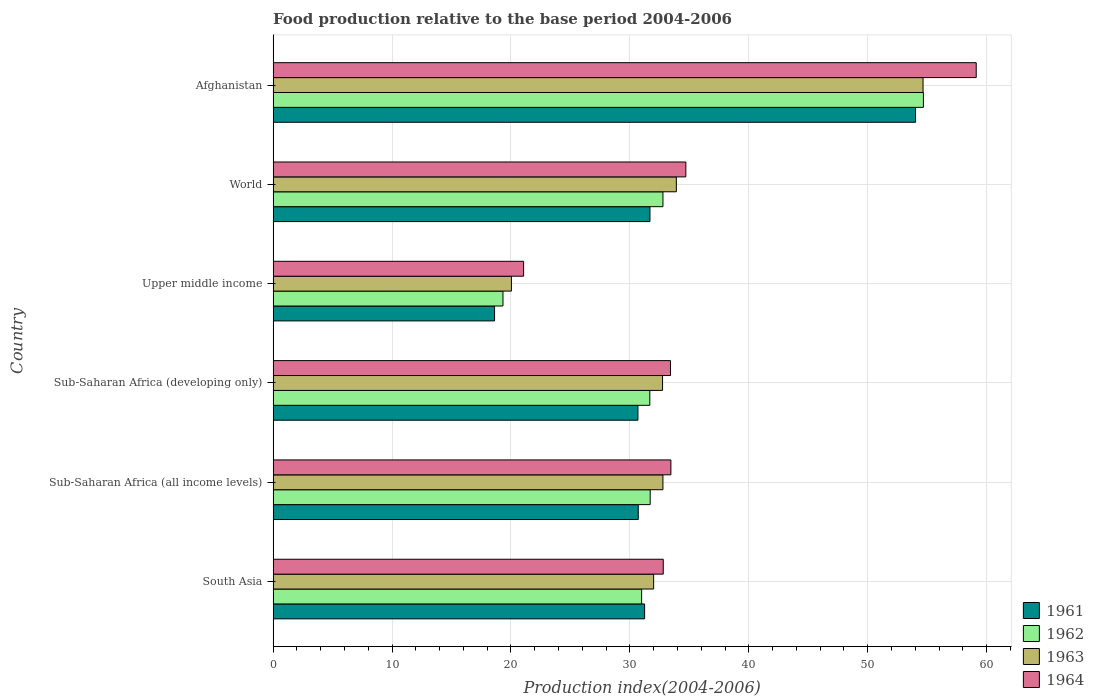How many different coloured bars are there?
Your answer should be very brief. 4. How many groups of bars are there?
Your response must be concise. 6. Are the number of bars on each tick of the Y-axis equal?
Your answer should be very brief. Yes. How many bars are there on the 5th tick from the top?
Offer a terse response. 4. What is the label of the 2nd group of bars from the top?
Your response must be concise. World. What is the food production index in 1961 in Sub-Saharan Africa (developing only)?
Provide a short and direct response. 30.68. Across all countries, what is the maximum food production index in 1962?
Provide a short and direct response. 54.68. Across all countries, what is the minimum food production index in 1964?
Offer a very short reply. 21.06. In which country was the food production index in 1962 maximum?
Your answer should be very brief. Afghanistan. In which country was the food production index in 1963 minimum?
Provide a succinct answer. Upper middle income. What is the total food production index in 1964 in the graph?
Make the answer very short. 214.55. What is the difference between the food production index in 1962 in Afghanistan and that in Upper middle income?
Provide a succinct answer. 35.35. What is the difference between the food production index in 1963 in Sub-Saharan Africa (all income levels) and the food production index in 1962 in Upper middle income?
Provide a short and direct response. 13.45. What is the average food production index in 1961 per country?
Make the answer very short. 32.82. What is the difference between the food production index in 1961 and food production index in 1962 in World?
Your answer should be very brief. -1.09. In how many countries, is the food production index in 1961 greater than 20 ?
Make the answer very short. 5. What is the ratio of the food production index in 1961 in South Asia to that in World?
Provide a succinct answer. 0.99. Is the food production index in 1964 in Sub-Saharan Africa (all income levels) less than that in World?
Your response must be concise. Yes. What is the difference between the highest and the second highest food production index in 1961?
Your response must be concise. 22.33. What is the difference between the highest and the lowest food production index in 1963?
Your answer should be very brief. 34.61. In how many countries, is the food production index in 1964 greater than the average food production index in 1964 taken over all countries?
Provide a short and direct response. 1. Is the sum of the food production index in 1964 in Afghanistan and Sub-Saharan Africa (all income levels) greater than the maximum food production index in 1963 across all countries?
Your answer should be compact. Yes. Is it the case that in every country, the sum of the food production index in 1961 and food production index in 1962 is greater than the sum of food production index in 1963 and food production index in 1964?
Make the answer very short. No. What does the 3rd bar from the top in World represents?
Offer a terse response. 1962. What is the difference between two consecutive major ticks on the X-axis?
Your answer should be compact. 10. Are the values on the major ticks of X-axis written in scientific E-notation?
Provide a succinct answer. No. Where does the legend appear in the graph?
Provide a short and direct response. Bottom right. How many legend labels are there?
Offer a terse response. 4. What is the title of the graph?
Your answer should be compact. Food production relative to the base period 2004-2006. What is the label or title of the X-axis?
Offer a terse response. Production index(2004-2006). What is the Production index(2004-2006) in 1961 in South Asia?
Make the answer very short. 31.24. What is the Production index(2004-2006) in 1962 in South Asia?
Offer a very short reply. 30.99. What is the Production index(2004-2006) of 1963 in South Asia?
Your answer should be compact. 32. What is the Production index(2004-2006) in 1964 in South Asia?
Your answer should be very brief. 32.8. What is the Production index(2004-2006) of 1961 in Sub-Saharan Africa (all income levels)?
Your answer should be very brief. 30.7. What is the Production index(2004-2006) of 1962 in Sub-Saharan Africa (all income levels)?
Keep it short and to the point. 31.71. What is the Production index(2004-2006) in 1963 in Sub-Saharan Africa (all income levels)?
Your response must be concise. 32.78. What is the Production index(2004-2006) in 1964 in Sub-Saharan Africa (all income levels)?
Provide a succinct answer. 33.45. What is the Production index(2004-2006) in 1961 in Sub-Saharan Africa (developing only)?
Ensure brevity in your answer.  30.68. What is the Production index(2004-2006) in 1962 in Sub-Saharan Africa (developing only)?
Provide a short and direct response. 31.68. What is the Production index(2004-2006) of 1963 in Sub-Saharan Africa (developing only)?
Offer a terse response. 32.75. What is the Production index(2004-2006) of 1964 in Sub-Saharan Africa (developing only)?
Provide a succinct answer. 33.41. What is the Production index(2004-2006) of 1961 in Upper middle income?
Provide a succinct answer. 18.62. What is the Production index(2004-2006) in 1962 in Upper middle income?
Ensure brevity in your answer.  19.33. What is the Production index(2004-2006) of 1963 in Upper middle income?
Your answer should be compact. 20.04. What is the Production index(2004-2006) in 1964 in Upper middle income?
Make the answer very short. 21.06. What is the Production index(2004-2006) in 1961 in World?
Offer a terse response. 31.69. What is the Production index(2004-2006) in 1962 in World?
Ensure brevity in your answer.  32.78. What is the Production index(2004-2006) in 1963 in World?
Your response must be concise. 33.91. What is the Production index(2004-2006) in 1964 in World?
Keep it short and to the point. 34.7. What is the Production index(2004-2006) in 1961 in Afghanistan?
Give a very brief answer. 54.02. What is the Production index(2004-2006) of 1962 in Afghanistan?
Give a very brief answer. 54.68. What is the Production index(2004-2006) of 1963 in Afghanistan?
Ensure brevity in your answer.  54.65. What is the Production index(2004-2006) in 1964 in Afghanistan?
Your answer should be very brief. 59.12. Across all countries, what is the maximum Production index(2004-2006) in 1961?
Make the answer very short. 54.02. Across all countries, what is the maximum Production index(2004-2006) of 1962?
Your answer should be compact. 54.68. Across all countries, what is the maximum Production index(2004-2006) in 1963?
Offer a terse response. 54.65. Across all countries, what is the maximum Production index(2004-2006) of 1964?
Your answer should be compact. 59.12. Across all countries, what is the minimum Production index(2004-2006) of 1961?
Offer a terse response. 18.62. Across all countries, what is the minimum Production index(2004-2006) in 1962?
Ensure brevity in your answer.  19.33. Across all countries, what is the minimum Production index(2004-2006) of 1963?
Your answer should be compact. 20.04. Across all countries, what is the minimum Production index(2004-2006) of 1964?
Give a very brief answer. 21.06. What is the total Production index(2004-2006) in 1961 in the graph?
Offer a very short reply. 196.94. What is the total Production index(2004-2006) in 1962 in the graph?
Provide a short and direct response. 201.15. What is the total Production index(2004-2006) in 1963 in the graph?
Provide a succinct answer. 206.11. What is the total Production index(2004-2006) of 1964 in the graph?
Make the answer very short. 214.55. What is the difference between the Production index(2004-2006) in 1961 in South Asia and that in Sub-Saharan Africa (all income levels)?
Your answer should be compact. 0.54. What is the difference between the Production index(2004-2006) in 1962 in South Asia and that in Sub-Saharan Africa (all income levels)?
Provide a short and direct response. -0.72. What is the difference between the Production index(2004-2006) of 1963 in South Asia and that in Sub-Saharan Africa (all income levels)?
Provide a succinct answer. -0.78. What is the difference between the Production index(2004-2006) in 1964 in South Asia and that in Sub-Saharan Africa (all income levels)?
Provide a short and direct response. -0.64. What is the difference between the Production index(2004-2006) of 1961 in South Asia and that in Sub-Saharan Africa (developing only)?
Your answer should be compact. 0.56. What is the difference between the Production index(2004-2006) in 1962 in South Asia and that in Sub-Saharan Africa (developing only)?
Make the answer very short. -0.69. What is the difference between the Production index(2004-2006) of 1963 in South Asia and that in Sub-Saharan Africa (developing only)?
Your response must be concise. -0.75. What is the difference between the Production index(2004-2006) in 1964 in South Asia and that in Sub-Saharan Africa (developing only)?
Keep it short and to the point. -0.61. What is the difference between the Production index(2004-2006) of 1961 in South Asia and that in Upper middle income?
Your answer should be compact. 12.62. What is the difference between the Production index(2004-2006) in 1962 in South Asia and that in Upper middle income?
Your answer should be compact. 11.66. What is the difference between the Production index(2004-2006) in 1963 in South Asia and that in Upper middle income?
Provide a short and direct response. 11.96. What is the difference between the Production index(2004-2006) of 1964 in South Asia and that in Upper middle income?
Provide a short and direct response. 11.74. What is the difference between the Production index(2004-2006) in 1961 in South Asia and that in World?
Make the answer very short. -0.45. What is the difference between the Production index(2004-2006) of 1962 in South Asia and that in World?
Provide a short and direct response. -1.79. What is the difference between the Production index(2004-2006) in 1963 in South Asia and that in World?
Give a very brief answer. -1.91. What is the difference between the Production index(2004-2006) of 1964 in South Asia and that in World?
Give a very brief answer. -1.9. What is the difference between the Production index(2004-2006) of 1961 in South Asia and that in Afghanistan?
Offer a very short reply. -22.78. What is the difference between the Production index(2004-2006) of 1962 in South Asia and that in Afghanistan?
Offer a terse response. -23.69. What is the difference between the Production index(2004-2006) in 1963 in South Asia and that in Afghanistan?
Provide a short and direct response. -22.65. What is the difference between the Production index(2004-2006) in 1964 in South Asia and that in Afghanistan?
Ensure brevity in your answer.  -26.32. What is the difference between the Production index(2004-2006) in 1961 in Sub-Saharan Africa (all income levels) and that in Sub-Saharan Africa (developing only)?
Your response must be concise. 0.03. What is the difference between the Production index(2004-2006) in 1962 in Sub-Saharan Africa (all income levels) and that in Sub-Saharan Africa (developing only)?
Your response must be concise. 0.03. What is the difference between the Production index(2004-2006) of 1963 in Sub-Saharan Africa (all income levels) and that in Sub-Saharan Africa (developing only)?
Provide a short and direct response. 0.03. What is the difference between the Production index(2004-2006) of 1964 in Sub-Saharan Africa (all income levels) and that in Sub-Saharan Africa (developing only)?
Offer a very short reply. 0.04. What is the difference between the Production index(2004-2006) of 1961 in Sub-Saharan Africa (all income levels) and that in Upper middle income?
Your answer should be compact. 12.08. What is the difference between the Production index(2004-2006) in 1962 in Sub-Saharan Africa (all income levels) and that in Upper middle income?
Your answer should be compact. 12.38. What is the difference between the Production index(2004-2006) of 1963 in Sub-Saharan Africa (all income levels) and that in Upper middle income?
Ensure brevity in your answer.  12.74. What is the difference between the Production index(2004-2006) of 1964 in Sub-Saharan Africa (all income levels) and that in Upper middle income?
Keep it short and to the point. 12.38. What is the difference between the Production index(2004-2006) in 1961 in Sub-Saharan Africa (all income levels) and that in World?
Offer a very short reply. -0.98. What is the difference between the Production index(2004-2006) of 1962 in Sub-Saharan Africa (all income levels) and that in World?
Offer a terse response. -1.07. What is the difference between the Production index(2004-2006) in 1963 in Sub-Saharan Africa (all income levels) and that in World?
Offer a very short reply. -1.13. What is the difference between the Production index(2004-2006) in 1964 in Sub-Saharan Africa (all income levels) and that in World?
Make the answer very short. -1.26. What is the difference between the Production index(2004-2006) in 1961 in Sub-Saharan Africa (all income levels) and that in Afghanistan?
Offer a terse response. -23.32. What is the difference between the Production index(2004-2006) of 1962 in Sub-Saharan Africa (all income levels) and that in Afghanistan?
Your answer should be compact. -22.97. What is the difference between the Production index(2004-2006) of 1963 in Sub-Saharan Africa (all income levels) and that in Afghanistan?
Your answer should be very brief. -21.87. What is the difference between the Production index(2004-2006) of 1964 in Sub-Saharan Africa (all income levels) and that in Afghanistan?
Keep it short and to the point. -25.67. What is the difference between the Production index(2004-2006) in 1961 in Sub-Saharan Africa (developing only) and that in Upper middle income?
Ensure brevity in your answer.  12.06. What is the difference between the Production index(2004-2006) in 1962 in Sub-Saharan Africa (developing only) and that in Upper middle income?
Offer a terse response. 12.35. What is the difference between the Production index(2004-2006) in 1963 in Sub-Saharan Africa (developing only) and that in Upper middle income?
Give a very brief answer. 12.71. What is the difference between the Production index(2004-2006) in 1964 in Sub-Saharan Africa (developing only) and that in Upper middle income?
Your answer should be compact. 12.35. What is the difference between the Production index(2004-2006) of 1961 in Sub-Saharan Africa (developing only) and that in World?
Keep it short and to the point. -1.01. What is the difference between the Production index(2004-2006) of 1962 in Sub-Saharan Africa (developing only) and that in World?
Your answer should be very brief. -1.1. What is the difference between the Production index(2004-2006) in 1963 in Sub-Saharan Africa (developing only) and that in World?
Give a very brief answer. -1.16. What is the difference between the Production index(2004-2006) in 1964 in Sub-Saharan Africa (developing only) and that in World?
Your answer should be compact. -1.29. What is the difference between the Production index(2004-2006) in 1961 in Sub-Saharan Africa (developing only) and that in Afghanistan?
Make the answer very short. -23.34. What is the difference between the Production index(2004-2006) in 1962 in Sub-Saharan Africa (developing only) and that in Afghanistan?
Provide a succinct answer. -23. What is the difference between the Production index(2004-2006) in 1963 in Sub-Saharan Africa (developing only) and that in Afghanistan?
Your answer should be compact. -21.91. What is the difference between the Production index(2004-2006) in 1964 in Sub-Saharan Africa (developing only) and that in Afghanistan?
Your answer should be very brief. -25.71. What is the difference between the Production index(2004-2006) in 1961 in Upper middle income and that in World?
Provide a succinct answer. -13.07. What is the difference between the Production index(2004-2006) in 1962 in Upper middle income and that in World?
Your answer should be compact. -13.45. What is the difference between the Production index(2004-2006) of 1963 in Upper middle income and that in World?
Offer a terse response. -13.87. What is the difference between the Production index(2004-2006) in 1964 in Upper middle income and that in World?
Offer a terse response. -13.64. What is the difference between the Production index(2004-2006) in 1961 in Upper middle income and that in Afghanistan?
Make the answer very short. -35.4. What is the difference between the Production index(2004-2006) of 1962 in Upper middle income and that in Afghanistan?
Offer a terse response. -35.35. What is the difference between the Production index(2004-2006) of 1963 in Upper middle income and that in Afghanistan?
Provide a short and direct response. -34.61. What is the difference between the Production index(2004-2006) in 1964 in Upper middle income and that in Afghanistan?
Ensure brevity in your answer.  -38.06. What is the difference between the Production index(2004-2006) of 1961 in World and that in Afghanistan?
Offer a very short reply. -22.33. What is the difference between the Production index(2004-2006) in 1962 in World and that in Afghanistan?
Your answer should be very brief. -21.9. What is the difference between the Production index(2004-2006) in 1963 in World and that in Afghanistan?
Give a very brief answer. -20.74. What is the difference between the Production index(2004-2006) in 1964 in World and that in Afghanistan?
Offer a terse response. -24.42. What is the difference between the Production index(2004-2006) of 1961 in South Asia and the Production index(2004-2006) of 1962 in Sub-Saharan Africa (all income levels)?
Offer a very short reply. -0.47. What is the difference between the Production index(2004-2006) of 1961 in South Asia and the Production index(2004-2006) of 1963 in Sub-Saharan Africa (all income levels)?
Ensure brevity in your answer.  -1.54. What is the difference between the Production index(2004-2006) in 1961 in South Asia and the Production index(2004-2006) in 1964 in Sub-Saharan Africa (all income levels)?
Your answer should be very brief. -2.21. What is the difference between the Production index(2004-2006) of 1962 in South Asia and the Production index(2004-2006) of 1963 in Sub-Saharan Africa (all income levels)?
Ensure brevity in your answer.  -1.79. What is the difference between the Production index(2004-2006) in 1962 in South Asia and the Production index(2004-2006) in 1964 in Sub-Saharan Africa (all income levels)?
Offer a terse response. -2.46. What is the difference between the Production index(2004-2006) in 1963 in South Asia and the Production index(2004-2006) in 1964 in Sub-Saharan Africa (all income levels)?
Give a very brief answer. -1.45. What is the difference between the Production index(2004-2006) of 1961 in South Asia and the Production index(2004-2006) of 1962 in Sub-Saharan Africa (developing only)?
Your answer should be compact. -0.44. What is the difference between the Production index(2004-2006) in 1961 in South Asia and the Production index(2004-2006) in 1963 in Sub-Saharan Africa (developing only)?
Offer a very short reply. -1.51. What is the difference between the Production index(2004-2006) in 1961 in South Asia and the Production index(2004-2006) in 1964 in Sub-Saharan Africa (developing only)?
Offer a terse response. -2.17. What is the difference between the Production index(2004-2006) of 1962 in South Asia and the Production index(2004-2006) of 1963 in Sub-Saharan Africa (developing only)?
Ensure brevity in your answer.  -1.76. What is the difference between the Production index(2004-2006) of 1962 in South Asia and the Production index(2004-2006) of 1964 in Sub-Saharan Africa (developing only)?
Keep it short and to the point. -2.43. What is the difference between the Production index(2004-2006) in 1963 in South Asia and the Production index(2004-2006) in 1964 in Sub-Saharan Africa (developing only)?
Give a very brief answer. -1.42. What is the difference between the Production index(2004-2006) in 1961 in South Asia and the Production index(2004-2006) in 1962 in Upper middle income?
Offer a very short reply. 11.91. What is the difference between the Production index(2004-2006) in 1961 in South Asia and the Production index(2004-2006) in 1963 in Upper middle income?
Provide a short and direct response. 11.2. What is the difference between the Production index(2004-2006) in 1961 in South Asia and the Production index(2004-2006) in 1964 in Upper middle income?
Provide a succinct answer. 10.18. What is the difference between the Production index(2004-2006) in 1962 in South Asia and the Production index(2004-2006) in 1963 in Upper middle income?
Offer a very short reply. 10.95. What is the difference between the Production index(2004-2006) of 1962 in South Asia and the Production index(2004-2006) of 1964 in Upper middle income?
Ensure brevity in your answer.  9.92. What is the difference between the Production index(2004-2006) in 1963 in South Asia and the Production index(2004-2006) in 1964 in Upper middle income?
Keep it short and to the point. 10.93. What is the difference between the Production index(2004-2006) of 1961 in South Asia and the Production index(2004-2006) of 1962 in World?
Your answer should be very brief. -1.54. What is the difference between the Production index(2004-2006) in 1961 in South Asia and the Production index(2004-2006) in 1963 in World?
Your answer should be very brief. -2.67. What is the difference between the Production index(2004-2006) of 1961 in South Asia and the Production index(2004-2006) of 1964 in World?
Keep it short and to the point. -3.47. What is the difference between the Production index(2004-2006) of 1962 in South Asia and the Production index(2004-2006) of 1963 in World?
Offer a very short reply. -2.92. What is the difference between the Production index(2004-2006) in 1962 in South Asia and the Production index(2004-2006) in 1964 in World?
Provide a succinct answer. -3.72. What is the difference between the Production index(2004-2006) in 1963 in South Asia and the Production index(2004-2006) in 1964 in World?
Make the answer very short. -2.71. What is the difference between the Production index(2004-2006) of 1961 in South Asia and the Production index(2004-2006) of 1962 in Afghanistan?
Your answer should be compact. -23.44. What is the difference between the Production index(2004-2006) of 1961 in South Asia and the Production index(2004-2006) of 1963 in Afghanistan?
Your answer should be compact. -23.41. What is the difference between the Production index(2004-2006) of 1961 in South Asia and the Production index(2004-2006) of 1964 in Afghanistan?
Your answer should be compact. -27.88. What is the difference between the Production index(2004-2006) of 1962 in South Asia and the Production index(2004-2006) of 1963 in Afghanistan?
Keep it short and to the point. -23.66. What is the difference between the Production index(2004-2006) of 1962 in South Asia and the Production index(2004-2006) of 1964 in Afghanistan?
Offer a terse response. -28.13. What is the difference between the Production index(2004-2006) of 1963 in South Asia and the Production index(2004-2006) of 1964 in Afghanistan?
Make the answer very short. -27.12. What is the difference between the Production index(2004-2006) in 1961 in Sub-Saharan Africa (all income levels) and the Production index(2004-2006) in 1962 in Sub-Saharan Africa (developing only)?
Give a very brief answer. -0.97. What is the difference between the Production index(2004-2006) in 1961 in Sub-Saharan Africa (all income levels) and the Production index(2004-2006) in 1963 in Sub-Saharan Africa (developing only)?
Keep it short and to the point. -2.04. What is the difference between the Production index(2004-2006) of 1961 in Sub-Saharan Africa (all income levels) and the Production index(2004-2006) of 1964 in Sub-Saharan Africa (developing only)?
Your answer should be very brief. -2.71. What is the difference between the Production index(2004-2006) in 1962 in Sub-Saharan Africa (all income levels) and the Production index(2004-2006) in 1963 in Sub-Saharan Africa (developing only)?
Offer a terse response. -1.04. What is the difference between the Production index(2004-2006) of 1962 in Sub-Saharan Africa (all income levels) and the Production index(2004-2006) of 1964 in Sub-Saharan Africa (developing only)?
Ensure brevity in your answer.  -1.71. What is the difference between the Production index(2004-2006) in 1963 in Sub-Saharan Africa (all income levels) and the Production index(2004-2006) in 1964 in Sub-Saharan Africa (developing only)?
Offer a very short reply. -0.63. What is the difference between the Production index(2004-2006) in 1961 in Sub-Saharan Africa (all income levels) and the Production index(2004-2006) in 1962 in Upper middle income?
Provide a succinct answer. 11.37. What is the difference between the Production index(2004-2006) of 1961 in Sub-Saharan Africa (all income levels) and the Production index(2004-2006) of 1963 in Upper middle income?
Your answer should be compact. 10.66. What is the difference between the Production index(2004-2006) of 1961 in Sub-Saharan Africa (all income levels) and the Production index(2004-2006) of 1964 in Upper middle income?
Keep it short and to the point. 9.64. What is the difference between the Production index(2004-2006) in 1962 in Sub-Saharan Africa (all income levels) and the Production index(2004-2006) in 1963 in Upper middle income?
Provide a short and direct response. 11.67. What is the difference between the Production index(2004-2006) in 1962 in Sub-Saharan Africa (all income levels) and the Production index(2004-2006) in 1964 in Upper middle income?
Your response must be concise. 10.64. What is the difference between the Production index(2004-2006) in 1963 in Sub-Saharan Africa (all income levels) and the Production index(2004-2006) in 1964 in Upper middle income?
Offer a very short reply. 11.71. What is the difference between the Production index(2004-2006) of 1961 in Sub-Saharan Africa (all income levels) and the Production index(2004-2006) of 1962 in World?
Make the answer very short. -2.08. What is the difference between the Production index(2004-2006) of 1961 in Sub-Saharan Africa (all income levels) and the Production index(2004-2006) of 1963 in World?
Provide a short and direct response. -3.2. What is the difference between the Production index(2004-2006) in 1961 in Sub-Saharan Africa (all income levels) and the Production index(2004-2006) in 1964 in World?
Provide a succinct answer. -4. What is the difference between the Production index(2004-2006) in 1962 in Sub-Saharan Africa (all income levels) and the Production index(2004-2006) in 1963 in World?
Make the answer very short. -2.2. What is the difference between the Production index(2004-2006) in 1962 in Sub-Saharan Africa (all income levels) and the Production index(2004-2006) in 1964 in World?
Keep it short and to the point. -3. What is the difference between the Production index(2004-2006) in 1963 in Sub-Saharan Africa (all income levels) and the Production index(2004-2006) in 1964 in World?
Your response must be concise. -1.93. What is the difference between the Production index(2004-2006) of 1961 in Sub-Saharan Africa (all income levels) and the Production index(2004-2006) of 1962 in Afghanistan?
Provide a short and direct response. -23.98. What is the difference between the Production index(2004-2006) of 1961 in Sub-Saharan Africa (all income levels) and the Production index(2004-2006) of 1963 in Afghanistan?
Your answer should be compact. -23.95. What is the difference between the Production index(2004-2006) of 1961 in Sub-Saharan Africa (all income levels) and the Production index(2004-2006) of 1964 in Afghanistan?
Give a very brief answer. -28.42. What is the difference between the Production index(2004-2006) in 1962 in Sub-Saharan Africa (all income levels) and the Production index(2004-2006) in 1963 in Afghanistan?
Keep it short and to the point. -22.94. What is the difference between the Production index(2004-2006) of 1962 in Sub-Saharan Africa (all income levels) and the Production index(2004-2006) of 1964 in Afghanistan?
Ensure brevity in your answer.  -27.41. What is the difference between the Production index(2004-2006) in 1963 in Sub-Saharan Africa (all income levels) and the Production index(2004-2006) in 1964 in Afghanistan?
Your answer should be compact. -26.34. What is the difference between the Production index(2004-2006) in 1961 in Sub-Saharan Africa (developing only) and the Production index(2004-2006) in 1962 in Upper middle income?
Offer a very short reply. 11.35. What is the difference between the Production index(2004-2006) of 1961 in Sub-Saharan Africa (developing only) and the Production index(2004-2006) of 1963 in Upper middle income?
Give a very brief answer. 10.64. What is the difference between the Production index(2004-2006) in 1961 in Sub-Saharan Africa (developing only) and the Production index(2004-2006) in 1964 in Upper middle income?
Your answer should be compact. 9.61. What is the difference between the Production index(2004-2006) in 1962 in Sub-Saharan Africa (developing only) and the Production index(2004-2006) in 1963 in Upper middle income?
Keep it short and to the point. 11.64. What is the difference between the Production index(2004-2006) of 1962 in Sub-Saharan Africa (developing only) and the Production index(2004-2006) of 1964 in Upper middle income?
Your answer should be very brief. 10.61. What is the difference between the Production index(2004-2006) in 1963 in Sub-Saharan Africa (developing only) and the Production index(2004-2006) in 1964 in Upper middle income?
Ensure brevity in your answer.  11.68. What is the difference between the Production index(2004-2006) in 1961 in Sub-Saharan Africa (developing only) and the Production index(2004-2006) in 1962 in World?
Ensure brevity in your answer.  -2.1. What is the difference between the Production index(2004-2006) in 1961 in Sub-Saharan Africa (developing only) and the Production index(2004-2006) in 1963 in World?
Your answer should be compact. -3.23. What is the difference between the Production index(2004-2006) of 1961 in Sub-Saharan Africa (developing only) and the Production index(2004-2006) of 1964 in World?
Make the answer very short. -4.03. What is the difference between the Production index(2004-2006) of 1962 in Sub-Saharan Africa (developing only) and the Production index(2004-2006) of 1963 in World?
Provide a succinct answer. -2.23. What is the difference between the Production index(2004-2006) of 1962 in Sub-Saharan Africa (developing only) and the Production index(2004-2006) of 1964 in World?
Provide a succinct answer. -3.03. What is the difference between the Production index(2004-2006) in 1963 in Sub-Saharan Africa (developing only) and the Production index(2004-2006) in 1964 in World?
Offer a terse response. -1.96. What is the difference between the Production index(2004-2006) in 1961 in Sub-Saharan Africa (developing only) and the Production index(2004-2006) in 1962 in Afghanistan?
Offer a terse response. -24. What is the difference between the Production index(2004-2006) of 1961 in Sub-Saharan Africa (developing only) and the Production index(2004-2006) of 1963 in Afghanistan?
Ensure brevity in your answer.  -23.97. What is the difference between the Production index(2004-2006) in 1961 in Sub-Saharan Africa (developing only) and the Production index(2004-2006) in 1964 in Afghanistan?
Keep it short and to the point. -28.44. What is the difference between the Production index(2004-2006) in 1962 in Sub-Saharan Africa (developing only) and the Production index(2004-2006) in 1963 in Afghanistan?
Your response must be concise. -22.97. What is the difference between the Production index(2004-2006) in 1962 in Sub-Saharan Africa (developing only) and the Production index(2004-2006) in 1964 in Afghanistan?
Give a very brief answer. -27.44. What is the difference between the Production index(2004-2006) of 1963 in Sub-Saharan Africa (developing only) and the Production index(2004-2006) of 1964 in Afghanistan?
Your answer should be very brief. -26.38. What is the difference between the Production index(2004-2006) in 1961 in Upper middle income and the Production index(2004-2006) in 1962 in World?
Your response must be concise. -14.16. What is the difference between the Production index(2004-2006) in 1961 in Upper middle income and the Production index(2004-2006) in 1963 in World?
Provide a succinct answer. -15.29. What is the difference between the Production index(2004-2006) in 1961 in Upper middle income and the Production index(2004-2006) in 1964 in World?
Keep it short and to the point. -16.08. What is the difference between the Production index(2004-2006) of 1962 in Upper middle income and the Production index(2004-2006) of 1963 in World?
Your response must be concise. -14.58. What is the difference between the Production index(2004-2006) in 1962 in Upper middle income and the Production index(2004-2006) in 1964 in World?
Your answer should be very brief. -15.38. What is the difference between the Production index(2004-2006) of 1963 in Upper middle income and the Production index(2004-2006) of 1964 in World?
Make the answer very short. -14.67. What is the difference between the Production index(2004-2006) of 1961 in Upper middle income and the Production index(2004-2006) of 1962 in Afghanistan?
Offer a very short reply. -36.06. What is the difference between the Production index(2004-2006) in 1961 in Upper middle income and the Production index(2004-2006) in 1963 in Afghanistan?
Your response must be concise. -36.03. What is the difference between the Production index(2004-2006) of 1961 in Upper middle income and the Production index(2004-2006) of 1964 in Afghanistan?
Your answer should be very brief. -40.5. What is the difference between the Production index(2004-2006) of 1962 in Upper middle income and the Production index(2004-2006) of 1963 in Afghanistan?
Provide a succinct answer. -35.32. What is the difference between the Production index(2004-2006) in 1962 in Upper middle income and the Production index(2004-2006) in 1964 in Afghanistan?
Keep it short and to the point. -39.79. What is the difference between the Production index(2004-2006) of 1963 in Upper middle income and the Production index(2004-2006) of 1964 in Afghanistan?
Ensure brevity in your answer.  -39.08. What is the difference between the Production index(2004-2006) in 1961 in World and the Production index(2004-2006) in 1962 in Afghanistan?
Your answer should be very brief. -22.99. What is the difference between the Production index(2004-2006) in 1961 in World and the Production index(2004-2006) in 1963 in Afghanistan?
Provide a succinct answer. -22.96. What is the difference between the Production index(2004-2006) of 1961 in World and the Production index(2004-2006) of 1964 in Afghanistan?
Provide a succinct answer. -27.43. What is the difference between the Production index(2004-2006) in 1962 in World and the Production index(2004-2006) in 1963 in Afghanistan?
Your answer should be very brief. -21.87. What is the difference between the Production index(2004-2006) in 1962 in World and the Production index(2004-2006) in 1964 in Afghanistan?
Keep it short and to the point. -26.34. What is the difference between the Production index(2004-2006) of 1963 in World and the Production index(2004-2006) of 1964 in Afghanistan?
Give a very brief answer. -25.21. What is the average Production index(2004-2006) in 1961 per country?
Offer a terse response. 32.82. What is the average Production index(2004-2006) of 1962 per country?
Provide a succinct answer. 33.53. What is the average Production index(2004-2006) of 1963 per country?
Make the answer very short. 34.35. What is the average Production index(2004-2006) in 1964 per country?
Provide a short and direct response. 35.76. What is the difference between the Production index(2004-2006) in 1961 and Production index(2004-2006) in 1962 in South Asia?
Provide a short and direct response. 0.25. What is the difference between the Production index(2004-2006) of 1961 and Production index(2004-2006) of 1963 in South Asia?
Keep it short and to the point. -0.76. What is the difference between the Production index(2004-2006) of 1961 and Production index(2004-2006) of 1964 in South Asia?
Your response must be concise. -1.57. What is the difference between the Production index(2004-2006) of 1962 and Production index(2004-2006) of 1963 in South Asia?
Offer a terse response. -1.01. What is the difference between the Production index(2004-2006) in 1962 and Production index(2004-2006) in 1964 in South Asia?
Make the answer very short. -1.82. What is the difference between the Production index(2004-2006) of 1963 and Production index(2004-2006) of 1964 in South Asia?
Offer a very short reply. -0.81. What is the difference between the Production index(2004-2006) in 1961 and Production index(2004-2006) in 1962 in Sub-Saharan Africa (all income levels)?
Your answer should be very brief. -1. What is the difference between the Production index(2004-2006) in 1961 and Production index(2004-2006) in 1963 in Sub-Saharan Africa (all income levels)?
Make the answer very short. -2.08. What is the difference between the Production index(2004-2006) in 1961 and Production index(2004-2006) in 1964 in Sub-Saharan Africa (all income levels)?
Provide a short and direct response. -2.74. What is the difference between the Production index(2004-2006) of 1962 and Production index(2004-2006) of 1963 in Sub-Saharan Africa (all income levels)?
Keep it short and to the point. -1.07. What is the difference between the Production index(2004-2006) of 1962 and Production index(2004-2006) of 1964 in Sub-Saharan Africa (all income levels)?
Offer a very short reply. -1.74. What is the difference between the Production index(2004-2006) of 1963 and Production index(2004-2006) of 1964 in Sub-Saharan Africa (all income levels)?
Give a very brief answer. -0.67. What is the difference between the Production index(2004-2006) of 1961 and Production index(2004-2006) of 1962 in Sub-Saharan Africa (developing only)?
Provide a succinct answer. -1. What is the difference between the Production index(2004-2006) in 1961 and Production index(2004-2006) in 1963 in Sub-Saharan Africa (developing only)?
Keep it short and to the point. -2.07. What is the difference between the Production index(2004-2006) of 1961 and Production index(2004-2006) of 1964 in Sub-Saharan Africa (developing only)?
Your answer should be compact. -2.74. What is the difference between the Production index(2004-2006) in 1962 and Production index(2004-2006) in 1963 in Sub-Saharan Africa (developing only)?
Your answer should be very brief. -1.07. What is the difference between the Production index(2004-2006) of 1962 and Production index(2004-2006) of 1964 in Sub-Saharan Africa (developing only)?
Make the answer very short. -1.74. What is the difference between the Production index(2004-2006) of 1961 and Production index(2004-2006) of 1962 in Upper middle income?
Offer a terse response. -0.71. What is the difference between the Production index(2004-2006) in 1961 and Production index(2004-2006) in 1963 in Upper middle income?
Provide a succinct answer. -1.42. What is the difference between the Production index(2004-2006) of 1961 and Production index(2004-2006) of 1964 in Upper middle income?
Offer a terse response. -2.44. What is the difference between the Production index(2004-2006) of 1962 and Production index(2004-2006) of 1963 in Upper middle income?
Your response must be concise. -0.71. What is the difference between the Production index(2004-2006) in 1962 and Production index(2004-2006) in 1964 in Upper middle income?
Keep it short and to the point. -1.73. What is the difference between the Production index(2004-2006) in 1963 and Production index(2004-2006) in 1964 in Upper middle income?
Offer a terse response. -1.02. What is the difference between the Production index(2004-2006) of 1961 and Production index(2004-2006) of 1962 in World?
Make the answer very short. -1.09. What is the difference between the Production index(2004-2006) in 1961 and Production index(2004-2006) in 1963 in World?
Make the answer very short. -2.22. What is the difference between the Production index(2004-2006) of 1961 and Production index(2004-2006) of 1964 in World?
Ensure brevity in your answer.  -3.02. What is the difference between the Production index(2004-2006) of 1962 and Production index(2004-2006) of 1963 in World?
Your answer should be compact. -1.13. What is the difference between the Production index(2004-2006) in 1962 and Production index(2004-2006) in 1964 in World?
Offer a terse response. -1.92. What is the difference between the Production index(2004-2006) of 1963 and Production index(2004-2006) of 1964 in World?
Keep it short and to the point. -0.8. What is the difference between the Production index(2004-2006) in 1961 and Production index(2004-2006) in 1962 in Afghanistan?
Offer a very short reply. -0.66. What is the difference between the Production index(2004-2006) in 1961 and Production index(2004-2006) in 1963 in Afghanistan?
Your answer should be very brief. -0.63. What is the difference between the Production index(2004-2006) of 1961 and Production index(2004-2006) of 1964 in Afghanistan?
Give a very brief answer. -5.1. What is the difference between the Production index(2004-2006) in 1962 and Production index(2004-2006) in 1963 in Afghanistan?
Offer a very short reply. 0.03. What is the difference between the Production index(2004-2006) in 1962 and Production index(2004-2006) in 1964 in Afghanistan?
Your answer should be very brief. -4.44. What is the difference between the Production index(2004-2006) of 1963 and Production index(2004-2006) of 1964 in Afghanistan?
Provide a succinct answer. -4.47. What is the ratio of the Production index(2004-2006) in 1961 in South Asia to that in Sub-Saharan Africa (all income levels)?
Give a very brief answer. 1.02. What is the ratio of the Production index(2004-2006) in 1962 in South Asia to that in Sub-Saharan Africa (all income levels)?
Your response must be concise. 0.98. What is the ratio of the Production index(2004-2006) of 1963 in South Asia to that in Sub-Saharan Africa (all income levels)?
Your response must be concise. 0.98. What is the ratio of the Production index(2004-2006) in 1964 in South Asia to that in Sub-Saharan Africa (all income levels)?
Ensure brevity in your answer.  0.98. What is the ratio of the Production index(2004-2006) in 1961 in South Asia to that in Sub-Saharan Africa (developing only)?
Offer a terse response. 1.02. What is the ratio of the Production index(2004-2006) in 1962 in South Asia to that in Sub-Saharan Africa (developing only)?
Keep it short and to the point. 0.98. What is the ratio of the Production index(2004-2006) in 1963 in South Asia to that in Sub-Saharan Africa (developing only)?
Give a very brief answer. 0.98. What is the ratio of the Production index(2004-2006) in 1964 in South Asia to that in Sub-Saharan Africa (developing only)?
Provide a succinct answer. 0.98. What is the ratio of the Production index(2004-2006) of 1961 in South Asia to that in Upper middle income?
Make the answer very short. 1.68. What is the ratio of the Production index(2004-2006) of 1962 in South Asia to that in Upper middle income?
Your response must be concise. 1.6. What is the ratio of the Production index(2004-2006) in 1963 in South Asia to that in Upper middle income?
Make the answer very short. 1.6. What is the ratio of the Production index(2004-2006) of 1964 in South Asia to that in Upper middle income?
Provide a succinct answer. 1.56. What is the ratio of the Production index(2004-2006) of 1961 in South Asia to that in World?
Your response must be concise. 0.99. What is the ratio of the Production index(2004-2006) of 1962 in South Asia to that in World?
Your response must be concise. 0.95. What is the ratio of the Production index(2004-2006) in 1963 in South Asia to that in World?
Your answer should be compact. 0.94. What is the ratio of the Production index(2004-2006) in 1964 in South Asia to that in World?
Offer a terse response. 0.95. What is the ratio of the Production index(2004-2006) of 1961 in South Asia to that in Afghanistan?
Make the answer very short. 0.58. What is the ratio of the Production index(2004-2006) of 1962 in South Asia to that in Afghanistan?
Make the answer very short. 0.57. What is the ratio of the Production index(2004-2006) in 1963 in South Asia to that in Afghanistan?
Your response must be concise. 0.59. What is the ratio of the Production index(2004-2006) of 1964 in South Asia to that in Afghanistan?
Your answer should be compact. 0.55. What is the ratio of the Production index(2004-2006) in 1962 in Sub-Saharan Africa (all income levels) to that in Sub-Saharan Africa (developing only)?
Keep it short and to the point. 1. What is the ratio of the Production index(2004-2006) in 1963 in Sub-Saharan Africa (all income levels) to that in Sub-Saharan Africa (developing only)?
Offer a very short reply. 1. What is the ratio of the Production index(2004-2006) in 1961 in Sub-Saharan Africa (all income levels) to that in Upper middle income?
Your answer should be very brief. 1.65. What is the ratio of the Production index(2004-2006) of 1962 in Sub-Saharan Africa (all income levels) to that in Upper middle income?
Provide a short and direct response. 1.64. What is the ratio of the Production index(2004-2006) in 1963 in Sub-Saharan Africa (all income levels) to that in Upper middle income?
Provide a succinct answer. 1.64. What is the ratio of the Production index(2004-2006) in 1964 in Sub-Saharan Africa (all income levels) to that in Upper middle income?
Offer a very short reply. 1.59. What is the ratio of the Production index(2004-2006) of 1962 in Sub-Saharan Africa (all income levels) to that in World?
Your response must be concise. 0.97. What is the ratio of the Production index(2004-2006) of 1963 in Sub-Saharan Africa (all income levels) to that in World?
Provide a succinct answer. 0.97. What is the ratio of the Production index(2004-2006) of 1964 in Sub-Saharan Africa (all income levels) to that in World?
Make the answer very short. 0.96. What is the ratio of the Production index(2004-2006) in 1961 in Sub-Saharan Africa (all income levels) to that in Afghanistan?
Your answer should be very brief. 0.57. What is the ratio of the Production index(2004-2006) in 1962 in Sub-Saharan Africa (all income levels) to that in Afghanistan?
Provide a short and direct response. 0.58. What is the ratio of the Production index(2004-2006) of 1963 in Sub-Saharan Africa (all income levels) to that in Afghanistan?
Give a very brief answer. 0.6. What is the ratio of the Production index(2004-2006) of 1964 in Sub-Saharan Africa (all income levels) to that in Afghanistan?
Your answer should be compact. 0.57. What is the ratio of the Production index(2004-2006) of 1961 in Sub-Saharan Africa (developing only) to that in Upper middle income?
Provide a succinct answer. 1.65. What is the ratio of the Production index(2004-2006) of 1962 in Sub-Saharan Africa (developing only) to that in Upper middle income?
Make the answer very short. 1.64. What is the ratio of the Production index(2004-2006) of 1963 in Sub-Saharan Africa (developing only) to that in Upper middle income?
Give a very brief answer. 1.63. What is the ratio of the Production index(2004-2006) of 1964 in Sub-Saharan Africa (developing only) to that in Upper middle income?
Offer a very short reply. 1.59. What is the ratio of the Production index(2004-2006) of 1961 in Sub-Saharan Africa (developing only) to that in World?
Your answer should be compact. 0.97. What is the ratio of the Production index(2004-2006) of 1962 in Sub-Saharan Africa (developing only) to that in World?
Provide a short and direct response. 0.97. What is the ratio of the Production index(2004-2006) in 1963 in Sub-Saharan Africa (developing only) to that in World?
Offer a terse response. 0.97. What is the ratio of the Production index(2004-2006) of 1964 in Sub-Saharan Africa (developing only) to that in World?
Give a very brief answer. 0.96. What is the ratio of the Production index(2004-2006) of 1961 in Sub-Saharan Africa (developing only) to that in Afghanistan?
Make the answer very short. 0.57. What is the ratio of the Production index(2004-2006) in 1962 in Sub-Saharan Africa (developing only) to that in Afghanistan?
Give a very brief answer. 0.58. What is the ratio of the Production index(2004-2006) in 1963 in Sub-Saharan Africa (developing only) to that in Afghanistan?
Give a very brief answer. 0.6. What is the ratio of the Production index(2004-2006) of 1964 in Sub-Saharan Africa (developing only) to that in Afghanistan?
Your answer should be compact. 0.57. What is the ratio of the Production index(2004-2006) of 1961 in Upper middle income to that in World?
Give a very brief answer. 0.59. What is the ratio of the Production index(2004-2006) in 1962 in Upper middle income to that in World?
Offer a terse response. 0.59. What is the ratio of the Production index(2004-2006) of 1963 in Upper middle income to that in World?
Give a very brief answer. 0.59. What is the ratio of the Production index(2004-2006) of 1964 in Upper middle income to that in World?
Keep it short and to the point. 0.61. What is the ratio of the Production index(2004-2006) in 1961 in Upper middle income to that in Afghanistan?
Your response must be concise. 0.34. What is the ratio of the Production index(2004-2006) in 1962 in Upper middle income to that in Afghanistan?
Keep it short and to the point. 0.35. What is the ratio of the Production index(2004-2006) of 1963 in Upper middle income to that in Afghanistan?
Provide a succinct answer. 0.37. What is the ratio of the Production index(2004-2006) of 1964 in Upper middle income to that in Afghanistan?
Your answer should be compact. 0.36. What is the ratio of the Production index(2004-2006) in 1961 in World to that in Afghanistan?
Provide a short and direct response. 0.59. What is the ratio of the Production index(2004-2006) in 1962 in World to that in Afghanistan?
Provide a short and direct response. 0.6. What is the ratio of the Production index(2004-2006) in 1963 in World to that in Afghanistan?
Your response must be concise. 0.62. What is the ratio of the Production index(2004-2006) of 1964 in World to that in Afghanistan?
Make the answer very short. 0.59. What is the difference between the highest and the second highest Production index(2004-2006) in 1961?
Your response must be concise. 22.33. What is the difference between the highest and the second highest Production index(2004-2006) of 1962?
Make the answer very short. 21.9. What is the difference between the highest and the second highest Production index(2004-2006) in 1963?
Provide a succinct answer. 20.74. What is the difference between the highest and the second highest Production index(2004-2006) in 1964?
Offer a very short reply. 24.42. What is the difference between the highest and the lowest Production index(2004-2006) of 1961?
Keep it short and to the point. 35.4. What is the difference between the highest and the lowest Production index(2004-2006) in 1962?
Make the answer very short. 35.35. What is the difference between the highest and the lowest Production index(2004-2006) in 1963?
Give a very brief answer. 34.61. What is the difference between the highest and the lowest Production index(2004-2006) in 1964?
Your response must be concise. 38.06. 